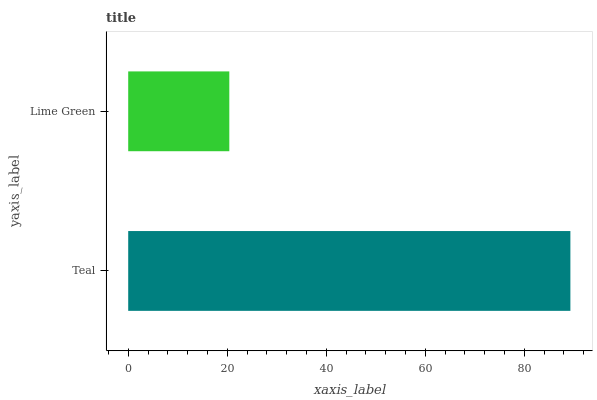Is Lime Green the minimum?
Answer yes or no. Yes. Is Teal the maximum?
Answer yes or no. Yes. Is Lime Green the maximum?
Answer yes or no. No. Is Teal greater than Lime Green?
Answer yes or no. Yes. Is Lime Green less than Teal?
Answer yes or no. Yes. Is Lime Green greater than Teal?
Answer yes or no. No. Is Teal less than Lime Green?
Answer yes or no. No. Is Teal the high median?
Answer yes or no. Yes. Is Lime Green the low median?
Answer yes or no. Yes. Is Lime Green the high median?
Answer yes or no. No. Is Teal the low median?
Answer yes or no. No. 